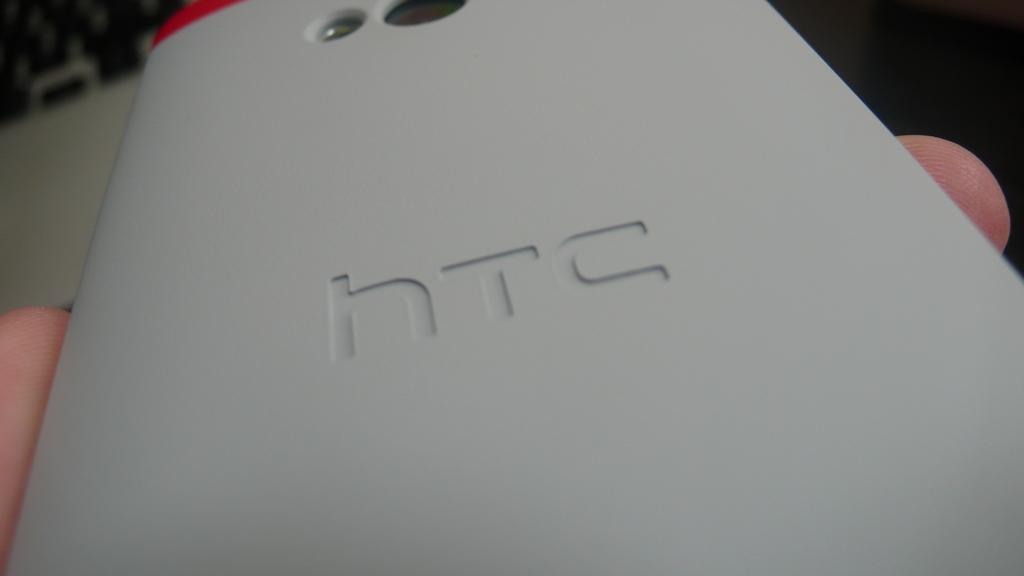What is the main subject of the image? The main subject of the image is a person. What is the person holding in the image? The person is holding an HTC mobile phone. Can you see a frog hopping on the person's shoulder in the image? There is no frog present in the image. What type of pencil is the person using to make adjustments on the mobile phone? There is no pencil visible in the image, and the person is not making any adjustments on the mobile phone. 